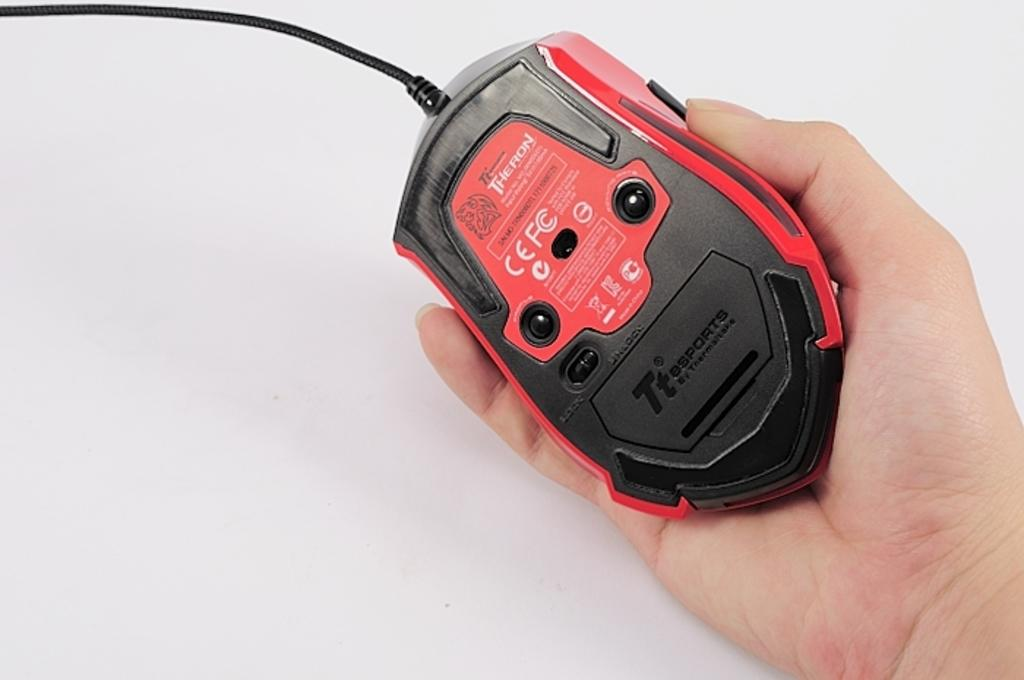What is the main subject of the image? There is a mouse in the image. What is the mouse doing in the image? The mouse is holding something with its hand. What color is the background of the image? The background of the image is white. What type of soda is the mouse drinking in the image? There is no soda present in the image; the mouse is holding something with its hand. How many pieces of coal can be seen in the image? There is no coal present in the image; it only features a mouse and a white background. 